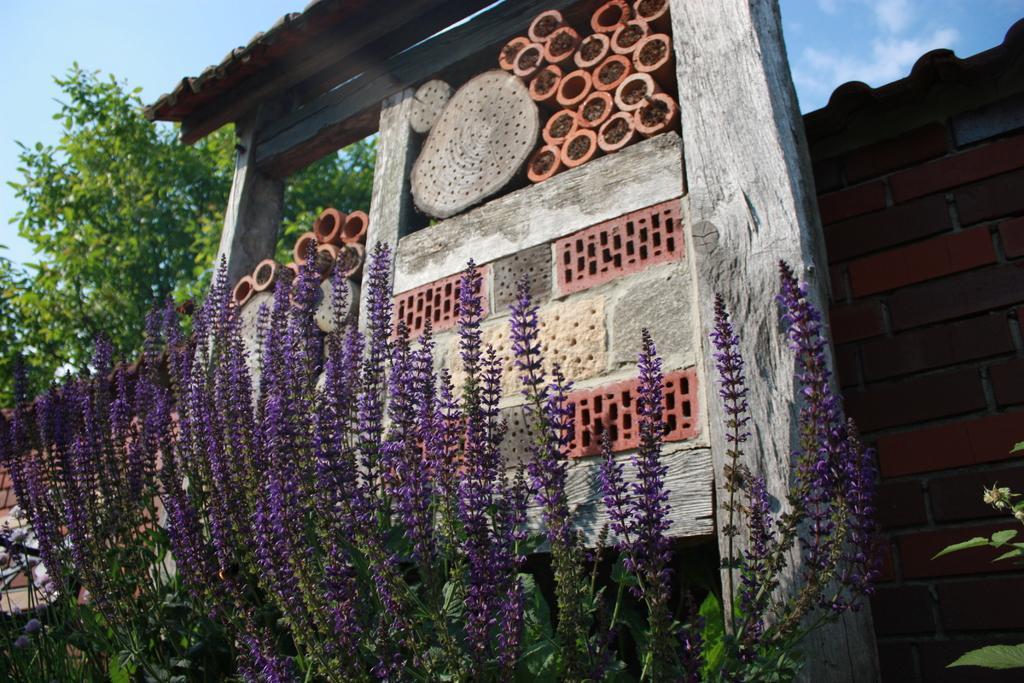How would you summarize this image in a sentence or two? In the picture I can see plants and trees. In the background I can see a brick wall, the sky and some other things. 